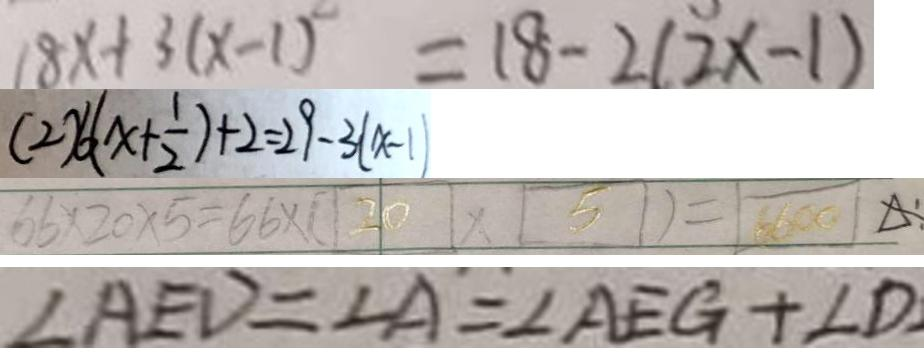Convert formula to latex. <formula><loc_0><loc_0><loc_500><loc_500>1 8 x + 3 ( x - 1 ) = 1 8 - 2 ( 2 x - 1 ) 
 ( 2 ) 6 ( x + \frac { 1 } { 2 } ) + 2 = 2 9 - 3 ( x - 1 ) 
 6 6 \times 2 0 \times 5 = 6 6 \times ( 2 0 \times 5 ) = 6 6 0 0 
 \angle A E D = \angle A = \angle A E G + \angle D</formula> 